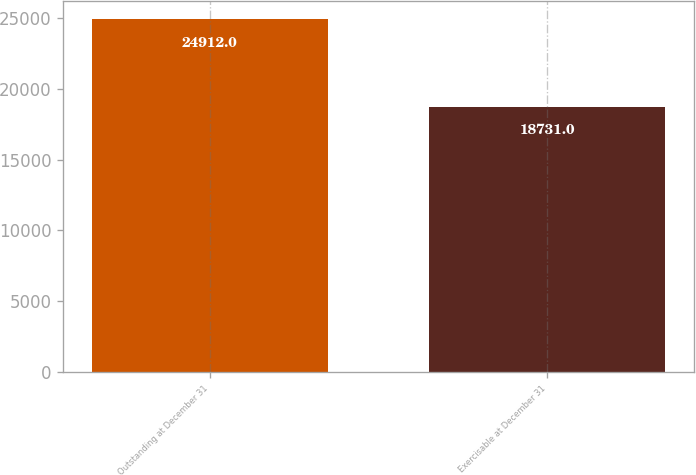Convert chart to OTSL. <chart><loc_0><loc_0><loc_500><loc_500><bar_chart><fcel>Outstanding at December 31<fcel>Exercisable at December 31<nl><fcel>24912<fcel>18731<nl></chart> 